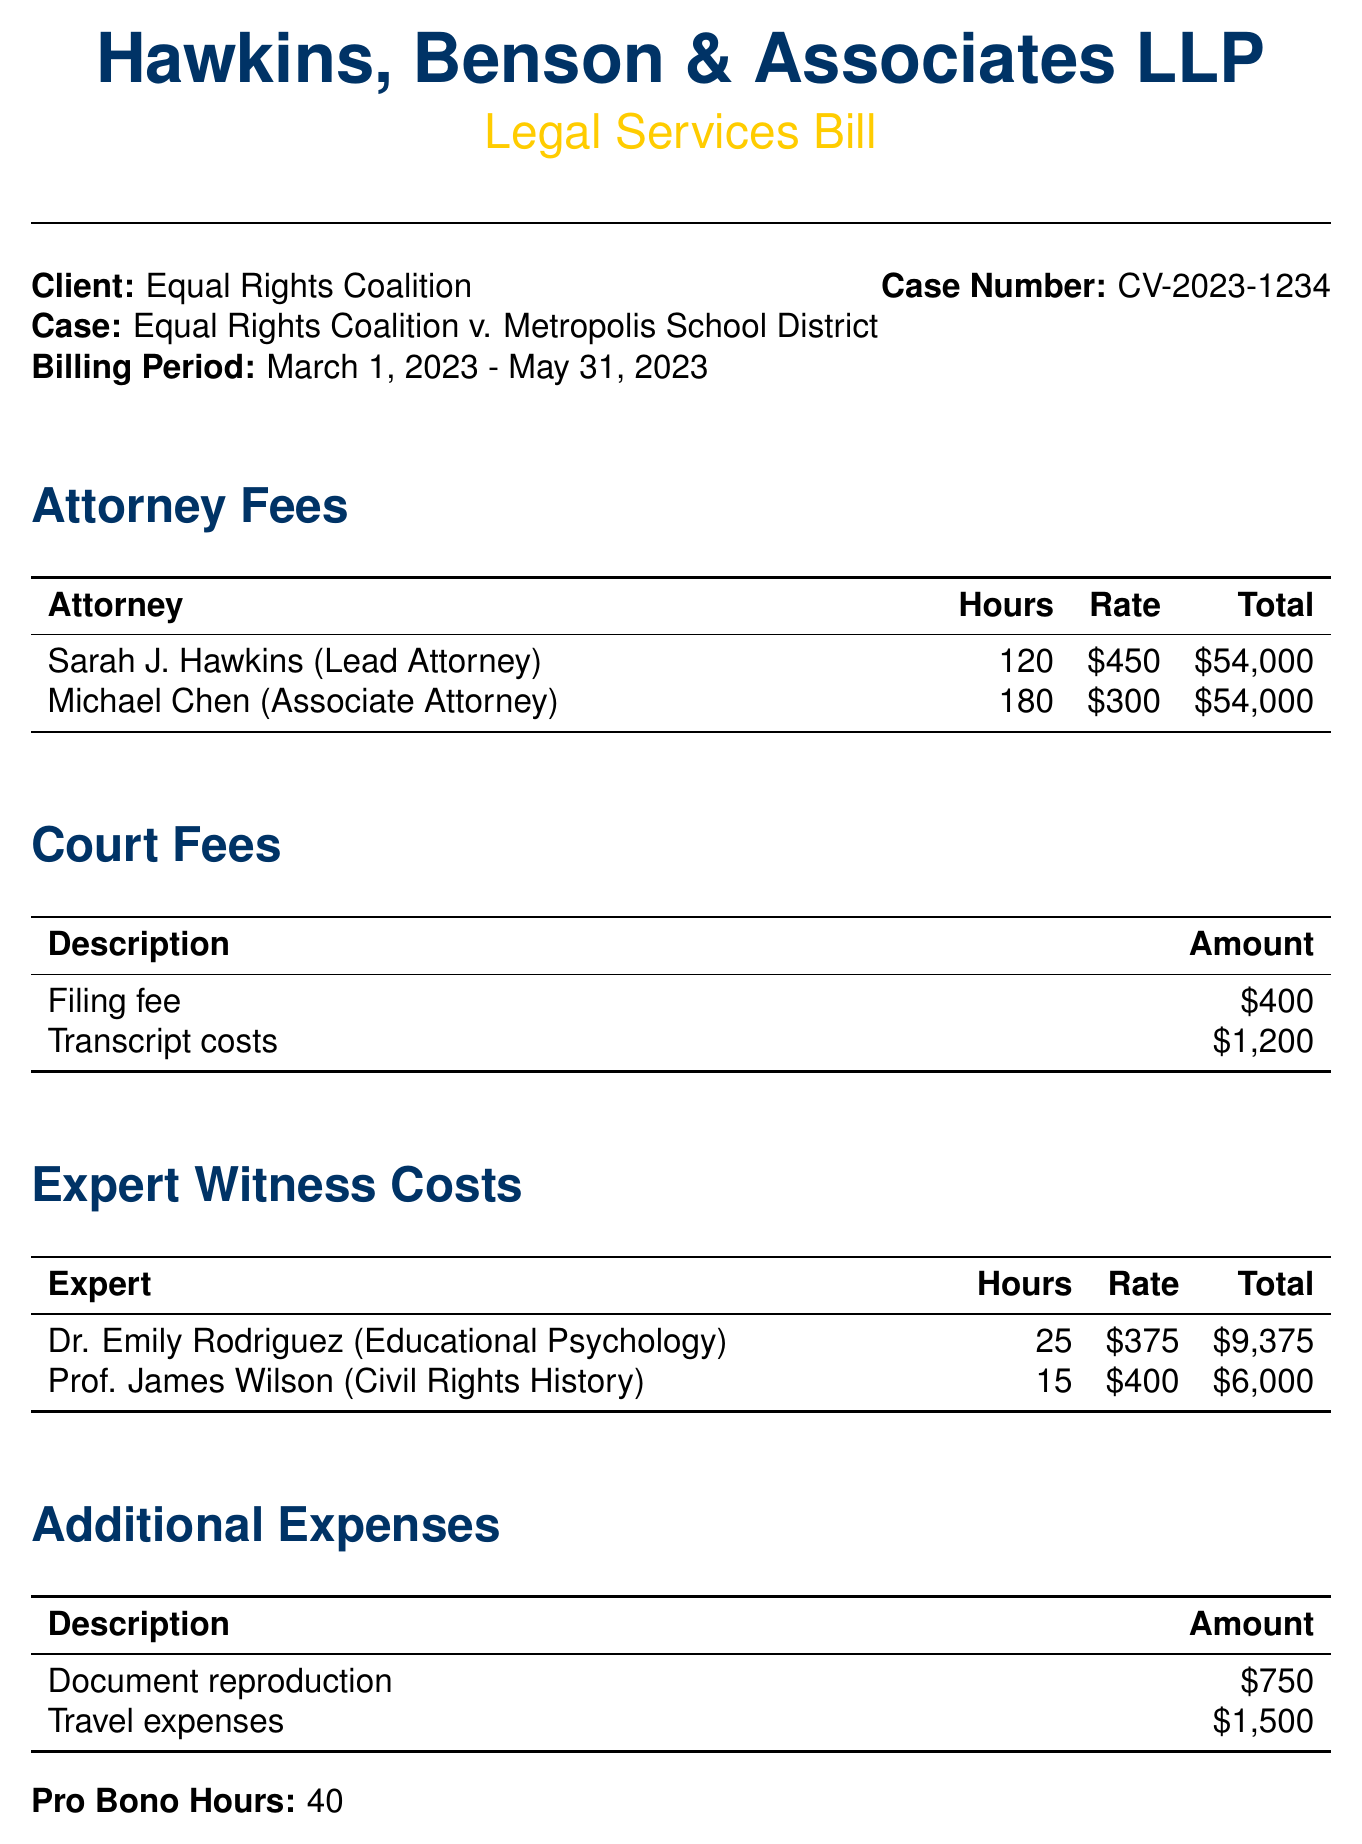What is the client name? The client name is stated at the beginning of the document under Client, which is Equal Rights Coalition.
Answer: Equal Rights Coalition What are the total hours billed by Michael Chen? The total hours billed by Michael Chen, listed under Attorney Fees, is 180.
Answer: 180 What is the total amount for court fees? The total amount for court fees includes the filing fee and transcript costs, totaling $400 + $1,200 = $1,600.
Answer: $1,600 How many hours did Dr. Emily Rodriguez spend? The document states that Dr. Emily Rodriguez spent 25 hours for the expert witness costs.
Answer: 25 What is the total billable amount? The total billable amount is calculated at the end of the document, summed as $137,850.
Answer: $137,850 What type of case is detailed in the document? The type of case is defined in the document heading as "Equal Rights Coalition v. Metropolis School District."
Answer: Equal Rights Coalition v. Metropolis School District How many pro bono hours were recorded? The document specifies that there were 40 pro bono hours included in the billing statement.
Answer: 40 What was the rate for Prof. James Wilson's expert witness costs? The rate for Prof. James Wilson's expert witness services is stated in the document as $400.
Answer: $400 What is the description of additional expenses listed? The additional expenses include document reproduction and travel expenses.
Answer: Document reproduction and travel expenses What is the filing fee amount? The filing fee amount is listed under Court Fees as $400.
Answer: $400 